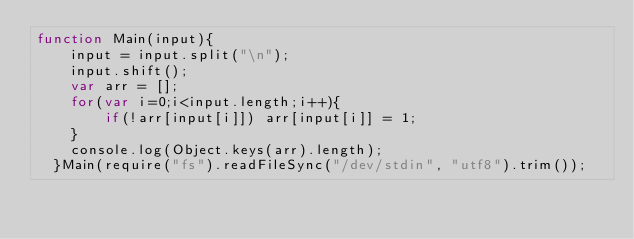<code> <loc_0><loc_0><loc_500><loc_500><_JavaScript_>function Main(input){
    input = input.split("\n");
    input.shift();
    var arr = [];
    for(var i=0;i<input.length;i++){
        if(!arr[input[i]]) arr[input[i]] = 1;
    }
    console.log(Object.keys(arr).length);
  }Main(require("fs").readFileSync("/dev/stdin", "utf8").trim());</code> 